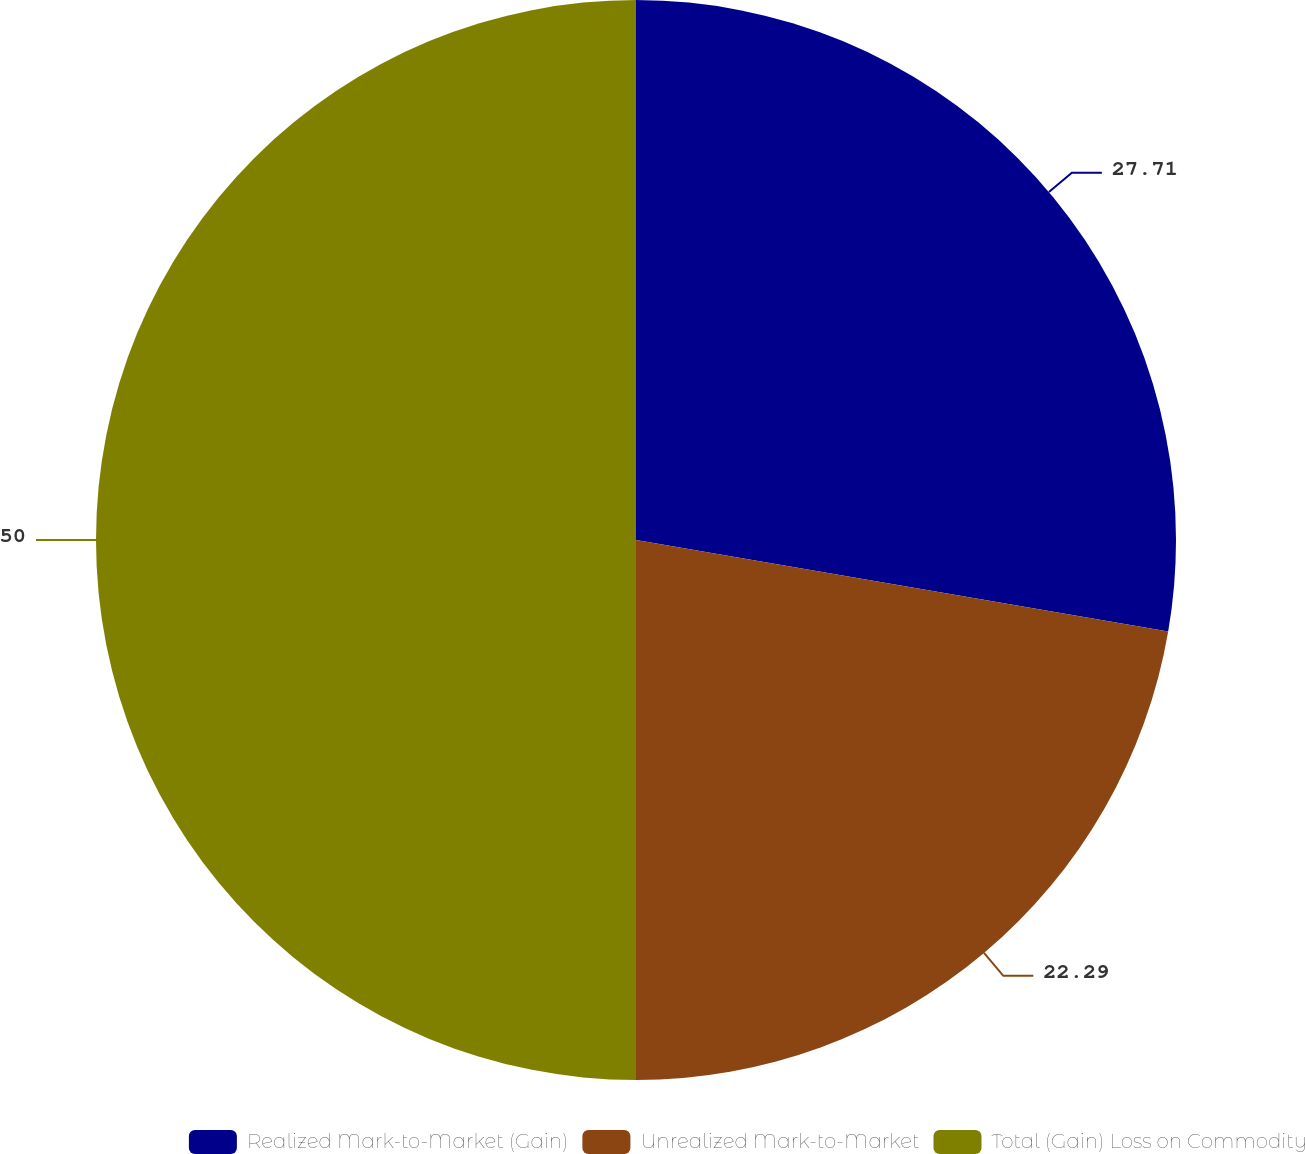<chart> <loc_0><loc_0><loc_500><loc_500><pie_chart><fcel>Realized Mark-to-Market (Gain)<fcel>Unrealized Mark-to-Market<fcel>Total (Gain) Loss on Commodity<nl><fcel>27.71%<fcel>22.29%<fcel>50.0%<nl></chart> 